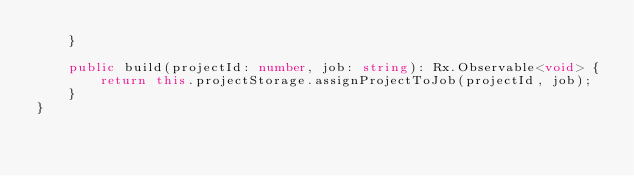<code> <loc_0><loc_0><loc_500><loc_500><_TypeScript_>    }

    public build(projectId: number, job: string): Rx.Observable<void> {
        return this.projectStorage.assignProjectToJob(projectId, job);
    }
}
</code> 